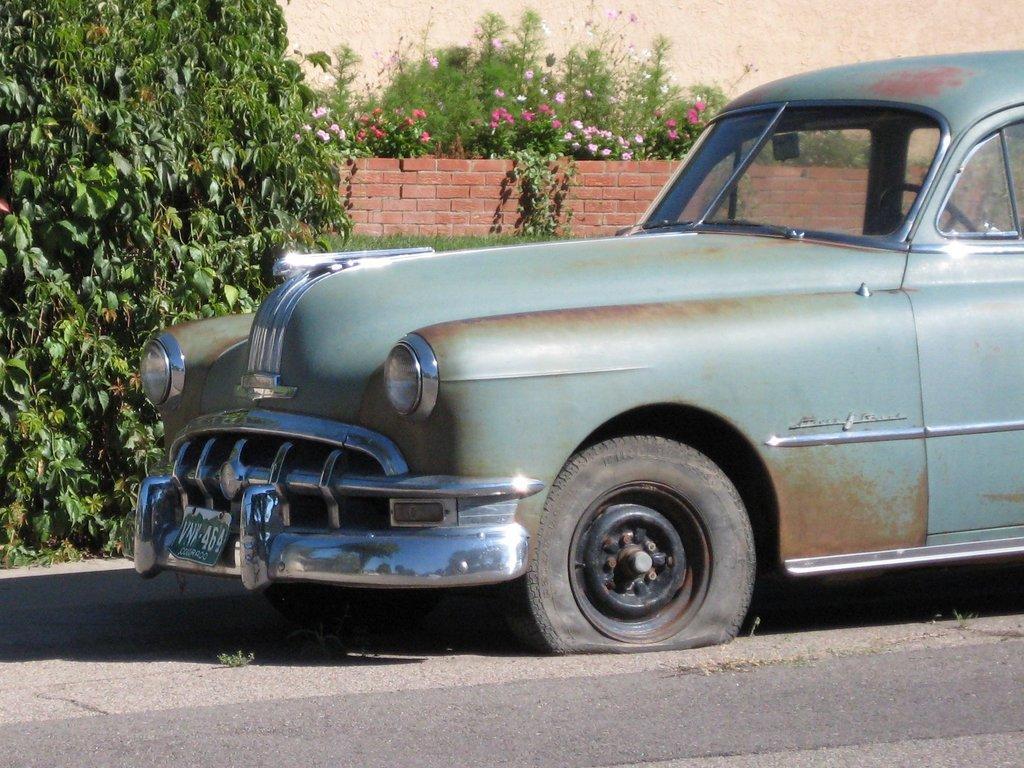Could you give a brief overview of what you see in this image? In this image we can see a car with a punctured tyre on the road. In the background we can see the tree, plants and also the brick wall. We can also see the plain wall. 